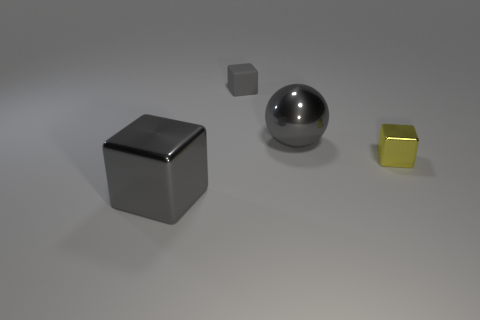There is a gray thing that is behind the big gray ball; is its size the same as the block left of the rubber cube?
Offer a terse response. No. There is a tiny matte block; is it the same color as the metal thing to the left of the metallic sphere?
Offer a terse response. Yes. What size is the yellow metal block to the right of the block to the left of the tiny gray object?
Offer a very short reply. Small. Does the metallic thing on the left side of the gray ball have the same shape as the small gray rubber object?
Ensure brevity in your answer.  Yes. Is there anything else that is the same shape as the small gray matte thing?
Ensure brevity in your answer.  Yes. There is a small gray thing; does it have the same shape as the large shiny object in front of the large gray ball?
Provide a succinct answer. Yes. There is another shiny thing that is the same shape as the small yellow metallic object; what is its size?
Make the answer very short. Large. There is a thing that is left of the gray metal ball and behind the tiny metallic thing; what is its size?
Offer a very short reply. Small. What is the material of the large object that is the same color as the large shiny cube?
Offer a terse response. Metal. How many large shiny things are the same color as the sphere?
Provide a succinct answer. 1. 